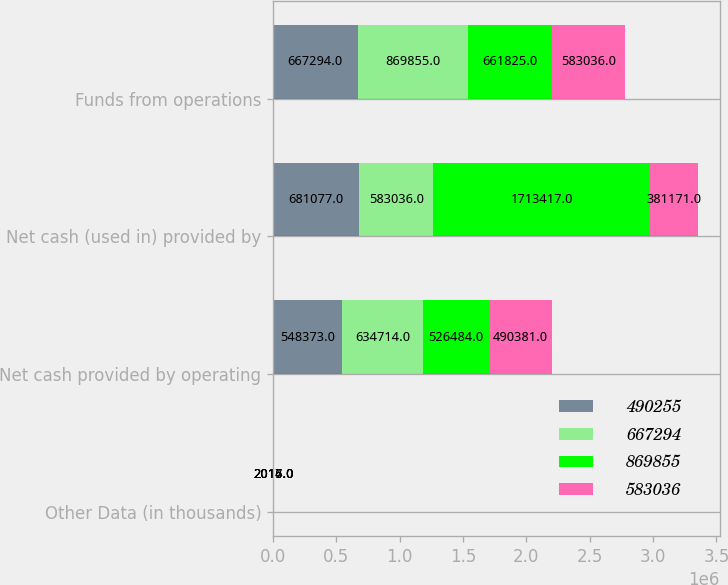Convert chart to OTSL. <chart><loc_0><loc_0><loc_500><loc_500><stacked_bar_chart><ecel><fcel>Other Data (in thousands)<fcel>Net cash provided by operating<fcel>Net cash (used in) provided by<fcel>Funds from operations<nl><fcel>490255<fcel>2017<fcel>548373<fcel>681077<fcel>667294<nl><fcel>667294<fcel>2016<fcel>634714<fcel>583036<fcel>869855<nl><fcel>869855<fcel>2015<fcel>526484<fcel>1.71342e+06<fcel>661825<nl><fcel>583036<fcel>2014<fcel>490381<fcel>381171<fcel>583036<nl></chart> 